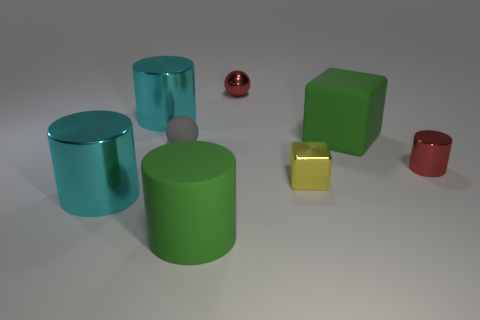What is the shape of the small red metallic thing that is behind the ball in front of the sphere that is behind the rubber block?
Give a very brief answer. Sphere. Is the number of tiny red metallic cylinders less than the number of tiny yellow cylinders?
Your response must be concise. No. Are there any gray spheres on the left side of the yellow metallic object?
Provide a short and direct response. Yes. What is the shape of the small shiny thing that is both in front of the large block and to the left of the large green cube?
Make the answer very short. Cube. Is there another tiny thing of the same shape as the yellow metallic object?
Offer a terse response. No. There is a green rubber thing that is left of the big rubber block; does it have the same size as the shiny cylinder right of the tiny rubber object?
Make the answer very short. No. Are there more red cylinders than red things?
Make the answer very short. No. How many spheres are made of the same material as the yellow object?
Your answer should be very brief. 1. There is a green rubber object that is on the left side of the big green thing to the right of the big green rubber cylinder that is in front of the metallic sphere; what is its size?
Give a very brief answer. Large. Is there a big green matte object that is to the left of the green matte object behind the green matte cylinder?
Keep it short and to the point. Yes. 